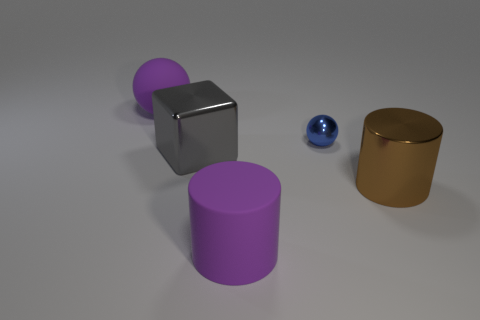Subtract 1 spheres. How many spheres are left? 1 Add 3 tiny cyan shiny spheres. How many objects exist? 8 Subtract all blocks. How many objects are left? 4 Add 2 big brown cylinders. How many big brown cylinders exist? 3 Subtract all brown cylinders. How many cylinders are left? 1 Subtract 1 brown cylinders. How many objects are left? 4 Subtract all yellow spheres. Subtract all yellow cylinders. How many spheres are left? 2 Subtract all gray cubes. How many brown cylinders are left? 1 Subtract all blue objects. Subtract all large rubber cylinders. How many objects are left? 3 Add 1 gray things. How many gray things are left? 2 